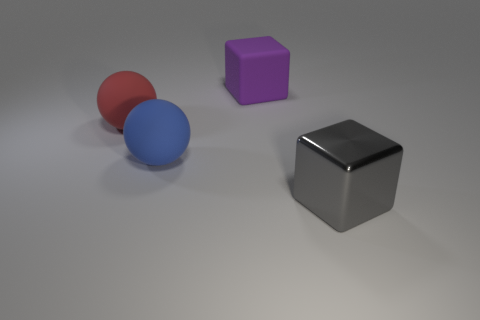Add 1 big gray spheres. How many objects exist? 5 Subtract all gray cubes. How many cubes are left? 1 Subtract 1 blue balls. How many objects are left? 3 Subtract all red cubes. Subtract all purple cylinders. How many cubes are left? 2 Subtract all blue spheres. How many red blocks are left? 0 Subtract all blue spheres. Subtract all big shiny cylinders. How many objects are left? 3 Add 1 big gray objects. How many big gray objects are left? 2 Add 4 small green metallic cylinders. How many small green metallic cylinders exist? 4 